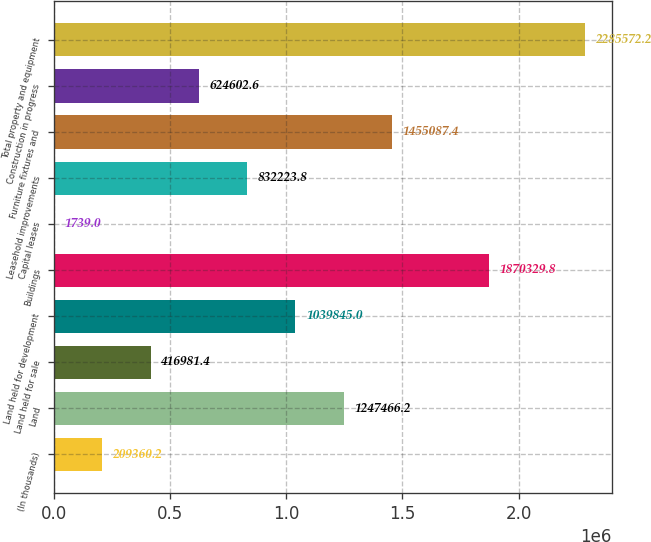Convert chart to OTSL. <chart><loc_0><loc_0><loc_500><loc_500><bar_chart><fcel>(In thousands)<fcel>Land<fcel>Land held for sale<fcel>Land held for development<fcel>Buildings<fcel>Capital leases<fcel>Leasehold improvements<fcel>Furniture fixtures and<fcel>Construction in progress<fcel>Total property and equipment<nl><fcel>209360<fcel>1.24747e+06<fcel>416981<fcel>1.03984e+06<fcel>1.87033e+06<fcel>1739<fcel>832224<fcel>1.45509e+06<fcel>624603<fcel>2.28557e+06<nl></chart> 